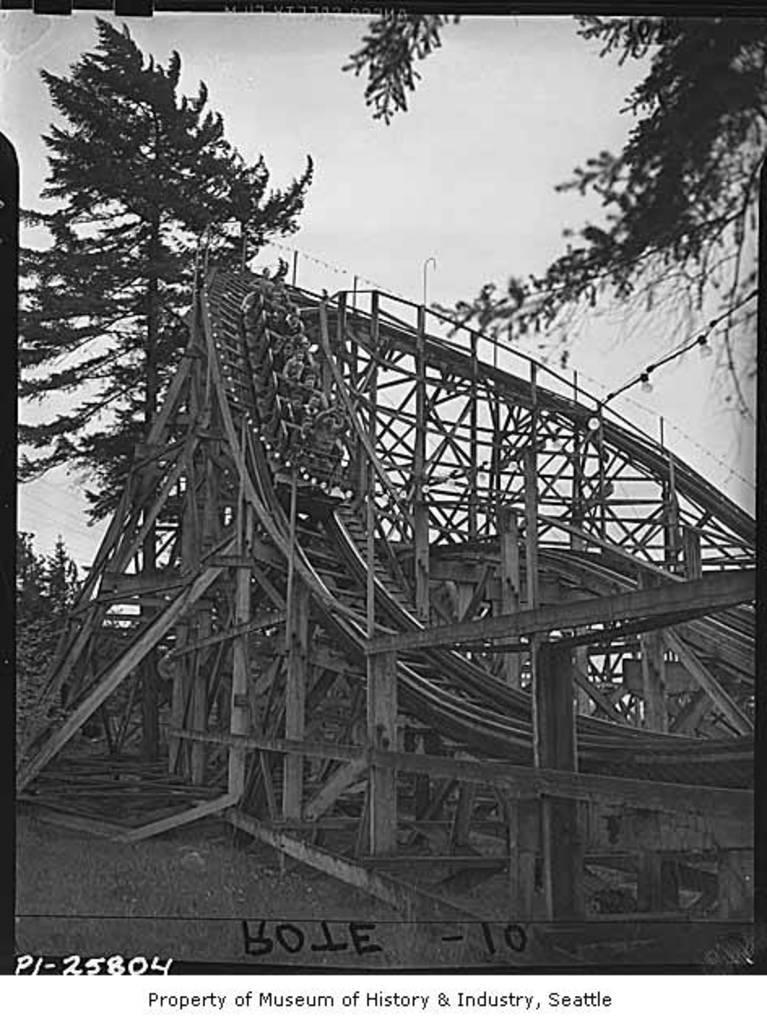Describe this image in one or two sentences. It looks like an old black and white picture. We can see a roller coaster and behind the roller coaster there are trees and the sky. On the image it is written something. 